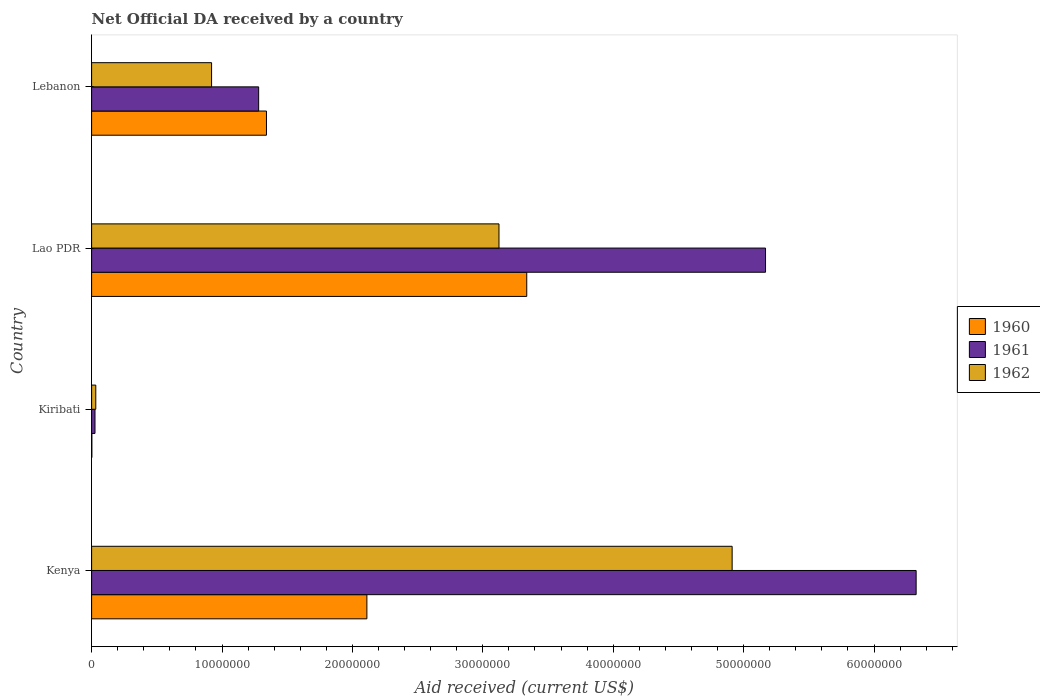How many groups of bars are there?
Make the answer very short. 4. How many bars are there on the 4th tick from the top?
Keep it short and to the point. 3. What is the label of the 3rd group of bars from the top?
Provide a short and direct response. Kiribati. In how many cases, is the number of bars for a given country not equal to the number of legend labels?
Give a very brief answer. 0. What is the net official development assistance aid received in 1961 in Lebanon?
Offer a terse response. 1.28e+07. Across all countries, what is the maximum net official development assistance aid received in 1960?
Offer a terse response. 3.34e+07. Across all countries, what is the minimum net official development assistance aid received in 1960?
Offer a terse response. 2.00e+04. In which country was the net official development assistance aid received in 1961 maximum?
Ensure brevity in your answer.  Kenya. In which country was the net official development assistance aid received in 1961 minimum?
Offer a very short reply. Kiribati. What is the total net official development assistance aid received in 1960 in the graph?
Your answer should be very brief. 6.79e+07. What is the difference between the net official development assistance aid received in 1960 in Kiribati and that in Lao PDR?
Your answer should be very brief. -3.34e+07. What is the difference between the net official development assistance aid received in 1961 in Lebanon and the net official development assistance aid received in 1960 in Kenya?
Your answer should be compact. -8.30e+06. What is the average net official development assistance aid received in 1962 per country?
Your response must be concise. 2.25e+07. What is the difference between the net official development assistance aid received in 1962 and net official development assistance aid received in 1960 in Lebanon?
Your response must be concise. -4.21e+06. What is the ratio of the net official development assistance aid received in 1961 in Kenya to that in Lao PDR?
Keep it short and to the point. 1.22. Is the difference between the net official development assistance aid received in 1962 in Kiribati and Lao PDR greater than the difference between the net official development assistance aid received in 1960 in Kiribati and Lao PDR?
Provide a succinct answer. Yes. What is the difference between the highest and the second highest net official development assistance aid received in 1960?
Provide a short and direct response. 1.23e+07. What is the difference between the highest and the lowest net official development assistance aid received in 1961?
Provide a short and direct response. 6.30e+07. Is the sum of the net official development assistance aid received in 1960 in Kenya and Kiribati greater than the maximum net official development assistance aid received in 1962 across all countries?
Offer a very short reply. No. Are all the bars in the graph horizontal?
Ensure brevity in your answer.  Yes. Are the values on the major ticks of X-axis written in scientific E-notation?
Provide a short and direct response. No. Does the graph contain any zero values?
Your answer should be very brief. No. Does the graph contain grids?
Ensure brevity in your answer.  No. How are the legend labels stacked?
Keep it short and to the point. Vertical. What is the title of the graph?
Give a very brief answer. Net Official DA received by a country. What is the label or title of the X-axis?
Keep it short and to the point. Aid received (current US$). What is the Aid received (current US$) in 1960 in Kenya?
Your answer should be compact. 2.11e+07. What is the Aid received (current US$) of 1961 in Kenya?
Provide a short and direct response. 6.32e+07. What is the Aid received (current US$) of 1962 in Kenya?
Your answer should be compact. 4.91e+07. What is the Aid received (current US$) in 1960 in Kiribati?
Your response must be concise. 2.00e+04. What is the Aid received (current US$) in 1961 in Kiribati?
Provide a short and direct response. 2.60e+05. What is the Aid received (current US$) of 1960 in Lao PDR?
Ensure brevity in your answer.  3.34e+07. What is the Aid received (current US$) in 1961 in Lao PDR?
Provide a succinct answer. 5.17e+07. What is the Aid received (current US$) of 1962 in Lao PDR?
Your answer should be very brief. 3.12e+07. What is the Aid received (current US$) of 1960 in Lebanon?
Offer a very short reply. 1.34e+07. What is the Aid received (current US$) of 1961 in Lebanon?
Your answer should be compact. 1.28e+07. What is the Aid received (current US$) of 1962 in Lebanon?
Your response must be concise. 9.20e+06. Across all countries, what is the maximum Aid received (current US$) of 1960?
Offer a very short reply. 3.34e+07. Across all countries, what is the maximum Aid received (current US$) of 1961?
Make the answer very short. 6.32e+07. Across all countries, what is the maximum Aid received (current US$) of 1962?
Offer a terse response. 4.91e+07. What is the total Aid received (current US$) of 1960 in the graph?
Keep it short and to the point. 6.79e+07. What is the total Aid received (current US$) of 1961 in the graph?
Offer a terse response. 1.28e+08. What is the total Aid received (current US$) of 1962 in the graph?
Make the answer very short. 8.99e+07. What is the difference between the Aid received (current US$) of 1960 in Kenya and that in Kiribati?
Your answer should be compact. 2.11e+07. What is the difference between the Aid received (current US$) of 1961 in Kenya and that in Kiribati?
Your answer should be compact. 6.30e+07. What is the difference between the Aid received (current US$) of 1962 in Kenya and that in Kiribati?
Give a very brief answer. 4.88e+07. What is the difference between the Aid received (current US$) in 1960 in Kenya and that in Lao PDR?
Offer a very short reply. -1.23e+07. What is the difference between the Aid received (current US$) of 1961 in Kenya and that in Lao PDR?
Provide a short and direct response. 1.16e+07. What is the difference between the Aid received (current US$) of 1962 in Kenya and that in Lao PDR?
Provide a short and direct response. 1.79e+07. What is the difference between the Aid received (current US$) in 1960 in Kenya and that in Lebanon?
Give a very brief answer. 7.70e+06. What is the difference between the Aid received (current US$) in 1961 in Kenya and that in Lebanon?
Ensure brevity in your answer.  5.04e+07. What is the difference between the Aid received (current US$) of 1962 in Kenya and that in Lebanon?
Your answer should be very brief. 3.99e+07. What is the difference between the Aid received (current US$) in 1960 in Kiribati and that in Lao PDR?
Your answer should be very brief. -3.34e+07. What is the difference between the Aid received (current US$) in 1961 in Kiribati and that in Lao PDR?
Your answer should be compact. -5.14e+07. What is the difference between the Aid received (current US$) in 1962 in Kiribati and that in Lao PDR?
Your answer should be very brief. -3.09e+07. What is the difference between the Aid received (current US$) in 1960 in Kiribati and that in Lebanon?
Make the answer very short. -1.34e+07. What is the difference between the Aid received (current US$) of 1961 in Kiribati and that in Lebanon?
Keep it short and to the point. -1.26e+07. What is the difference between the Aid received (current US$) of 1962 in Kiribati and that in Lebanon?
Your response must be concise. -8.88e+06. What is the difference between the Aid received (current US$) in 1960 in Lao PDR and that in Lebanon?
Provide a short and direct response. 2.00e+07. What is the difference between the Aid received (current US$) of 1961 in Lao PDR and that in Lebanon?
Offer a terse response. 3.89e+07. What is the difference between the Aid received (current US$) of 1962 in Lao PDR and that in Lebanon?
Keep it short and to the point. 2.20e+07. What is the difference between the Aid received (current US$) in 1960 in Kenya and the Aid received (current US$) in 1961 in Kiribati?
Keep it short and to the point. 2.08e+07. What is the difference between the Aid received (current US$) in 1960 in Kenya and the Aid received (current US$) in 1962 in Kiribati?
Offer a very short reply. 2.08e+07. What is the difference between the Aid received (current US$) of 1961 in Kenya and the Aid received (current US$) of 1962 in Kiribati?
Provide a short and direct response. 6.29e+07. What is the difference between the Aid received (current US$) of 1960 in Kenya and the Aid received (current US$) of 1961 in Lao PDR?
Offer a terse response. -3.06e+07. What is the difference between the Aid received (current US$) in 1960 in Kenya and the Aid received (current US$) in 1962 in Lao PDR?
Your answer should be very brief. -1.01e+07. What is the difference between the Aid received (current US$) of 1961 in Kenya and the Aid received (current US$) of 1962 in Lao PDR?
Make the answer very short. 3.20e+07. What is the difference between the Aid received (current US$) of 1960 in Kenya and the Aid received (current US$) of 1961 in Lebanon?
Your answer should be very brief. 8.30e+06. What is the difference between the Aid received (current US$) of 1960 in Kenya and the Aid received (current US$) of 1962 in Lebanon?
Offer a very short reply. 1.19e+07. What is the difference between the Aid received (current US$) in 1961 in Kenya and the Aid received (current US$) in 1962 in Lebanon?
Give a very brief answer. 5.40e+07. What is the difference between the Aid received (current US$) of 1960 in Kiribati and the Aid received (current US$) of 1961 in Lao PDR?
Your answer should be very brief. -5.17e+07. What is the difference between the Aid received (current US$) of 1960 in Kiribati and the Aid received (current US$) of 1962 in Lao PDR?
Keep it short and to the point. -3.12e+07. What is the difference between the Aid received (current US$) of 1961 in Kiribati and the Aid received (current US$) of 1962 in Lao PDR?
Offer a very short reply. -3.10e+07. What is the difference between the Aid received (current US$) of 1960 in Kiribati and the Aid received (current US$) of 1961 in Lebanon?
Ensure brevity in your answer.  -1.28e+07. What is the difference between the Aid received (current US$) in 1960 in Kiribati and the Aid received (current US$) in 1962 in Lebanon?
Your response must be concise. -9.18e+06. What is the difference between the Aid received (current US$) of 1961 in Kiribati and the Aid received (current US$) of 1962 in Lebanon?
Offer a terse response. -8.94e+06. What is the difference between the Aid received (current US$) in 1960 in Lao PDR and the Aid received (current US$) in 1961 in Lebanon?
Make the answer very short. 2.06e+07. What is the difference between the Aid received (current US$) of 1960 in Lao PDR and the Aid received (current US$) of 1962 in Lebanon?
Your response must be concise. 2.42e+07. What is the difference between the Aid received (current US$) of 1961 in Lao PDR and the Aid received (current US$) of 1962 in Lebanon?
Ensure brevity in your answer.  4.25e+07. What is the average Aid received (current US$) in 1960 per country?
Provide a succinct answer. 1.70e+07. What is the average Aid received (current US$) in 1961 per country?
Your answer should be compact. 3.20e+07. What is the average Aid received (current US$) in 1962 per country?
Offer a very short reply. 2.25e+07. What is the difference between the Aid received (current US$) in 1960 and Aid received (current US$) in 1961 in Kenya?
Make the answer very short. -4.21e+07. What is the difference between the Aid received (current US$) of 1960 and Aid received (current US$) of 1962 in Kenya?
Provide a short and direct response. -2.80e+07. What is the difference between the Aid received (current US$) in 1961 and Aid received (current US$) in 1962 in Kenya?
Offer a very short reply. 1.41e+07. What is the difference between the Aid received (current US$) of 1960 and Aid received (current US$) of 1962 in Kiribati?
Offer a very short reply. -3.00e+05. What is the difference between the Aid received (current US$) in 1961 and Aid received (current US$) in 1962 in Kiribati?
Your response must be concise. -6.00e+04. What is the difference between the Aid received (current US$) of 1960 and Aid received (current US$) of 1961 in Lao PDR?
Give a very brief answer. -1.83e+07. What is the difference between the Aid received (current US$) in 1960 and Aid received (current US$) in 1962 in Lao PDR?
Make the answer very short. 2.13e+06. What is the difference between the Aid received (current US$) in 1961 and Aid received (current US$) in 1962 in Lao PDR?
Offer a very short reply. 2.04e+07. What is the difference between the Aid received (current US$) of 1960 and Aid received (current US$) of 1962 in Lebanon?
Your answer should be very brief. 4.21e+06. What is the difference between the Aid received (current US$) in 1961 and Aid received (current US$) in 1962 in Lebanon?
Provide a succinct answer. 3.61e+06. What is the ratio of the Aid received (current US$) of 1960 in Kenya to that in Kiribati?
Ensure brevity in your answer.  1055.5. What is the ratio of the Aid received (current US$) in 1961 in Kenya to that in Kiribati?
Your response must be concise. 243.19. What is the ratio of the Aid received (current US$) of 1962 in Kenya to that in Kiribati?
Make the answer very short. 153.5. What is the ratio of the Aid received (current US$) in 1960 in Kenya to that in Lao PDR?
Keep it short and to the point. 0.63. What is the ratio of the Aid received (current US$) of 1961 in Kenya to that in Lao PDR?
Ensure brevity in your answer.  1.22. What is the ratio of the Aid received (current US$) of 1962 in Kenya to that in Lao PDR?
Your answer should be very brief. 1.57. What is the ratio of the Aid received (current US$) in 1960 in Kenya to that in Lebanon?
Offer a very short reply. 1.57. What is the ratio of the Aid received (current US$) in 1961 in Kenya to that in Lebanon?
Offer a very short reply. 4.94. What is the ratio of the Aid received (current US$) in 1962 in Kenya to that in Lebanon?
Offer a terse response. 5.34. What is the ratio of the Aid received (current US$) in 1960 in Kiribati to that in Lao PDR?
Ensure brevity in your answer.  0. What is the ratio of the Aid received (current US$) in 1961 in Kiribati to that in Lao PDR?
Keep it short and to the point. 0.01. What is the ratio of the Aid received (current US$) of 1962 in Kiribati to that in Lao PDR?
Provide a succinct answer. 0.01. What is the ratio of the Aid received (current US$) in 1960 in Kiribati to that in Lebanon?
Offer a very short reply. 0. What is the ratio of the Aid received (current US$) in 1961 in Kiribati to that in Lebanon?
Provide a short and direct response. 0.02. What is the ratio of the Aid received (current US$) of 1962 in Kiribati to that in Lebanon?
Keep it short and to the point. 0.03. What is the ratio of the Aid received (current US$) in 1960 in Lao PDR to that in Lebanon?
Your response must be concise. 2.49. What is the ratio of the Aid received (current US$) in 1961 in Lao PDR to that in Lebanon?
Give a very brief answer. 4.03. What is the ratio of the Aid received (current US$) in 1962 in Lao PDR to that in Lebanon?
Provide a succinct answer. 3.4. What is the difference between the highest and the second highest Aid received (current US$) of 1960?
Provide a short and direct response. 1.23e+07. What is the difference between the highest and the second highest Aid received (current US$) in 1961?
Offer a terse response. 1.16e+07. What is the difference between the highest and the second highest Aid received (current US$) in 1962?
Provide a short and direct response. 1.79e+07. What is the difference between the highest and the lowest Aid received (current US$) of 1960?
Provide a succinct answer. 3.34e+07. What is the difference between the highest and the lowest Aid received (current US$) of 1961?
Provide a short and direct response. 6.30e+07. What is the difference between the highest and the lowest Aid received (current US$) in 1962?
Make the answer very short. 4.88e+07. 